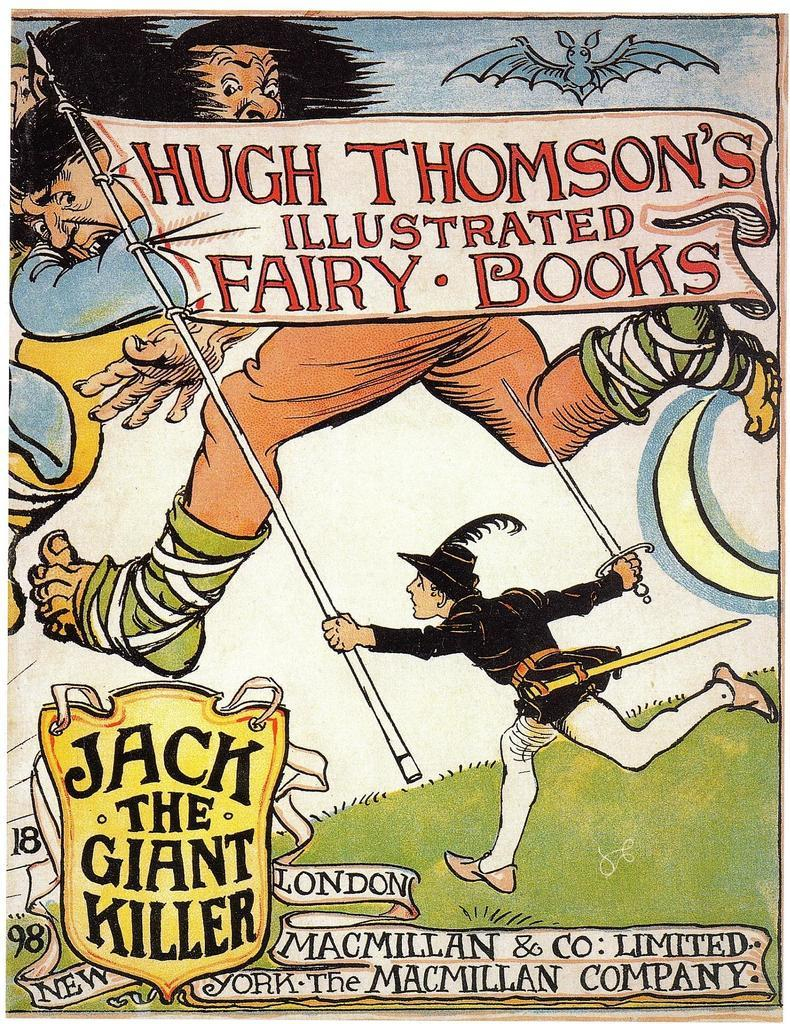<image>
Share a concise interpretation of the image provided. A cartoon picture of a giant, in the lower left the words "Jack the giant killer." 